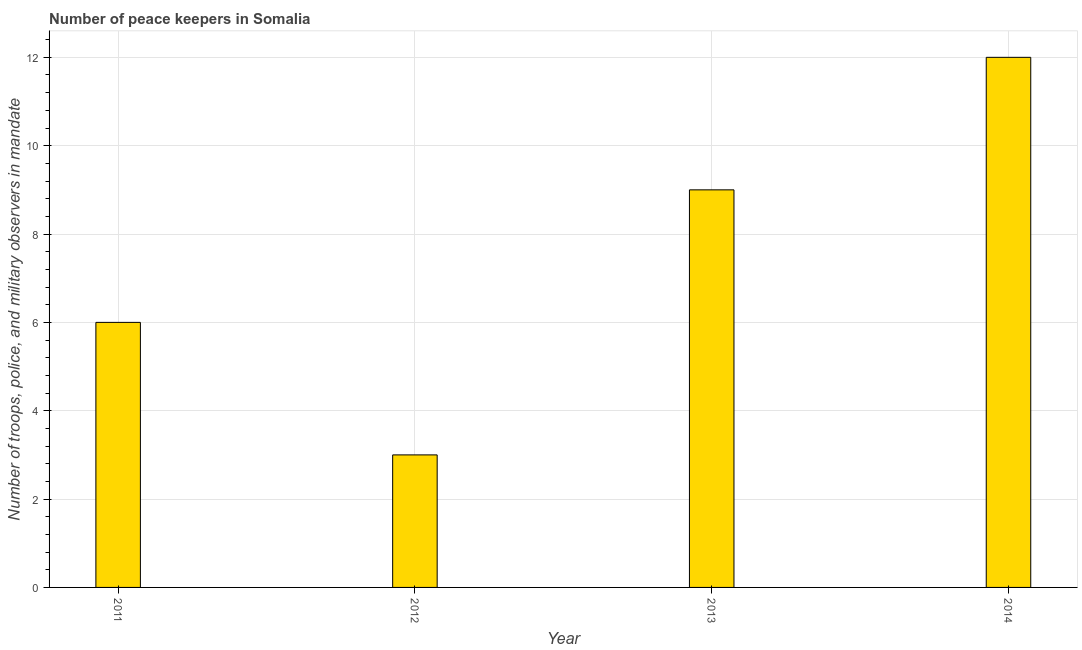Does the graph contain any zero values?
Offer a very short reply. No. What is the title of the graph?
Your response must be concise. Number of peace keepers in Somalia. What is the label or title of the Y-axis?
Keep it short and to the point. Number of troops, police, and military observers in mandate. Across all years, what is the maximum number of peace keepers?
Your answer should be compact. 12. Across all years, what is the minimum number of peace keepers?
Offer a very short reply. 3. In which year was the number of peace keepers maximum?
Keep it short and to the point. 2014. In which year was the number of peace keepers minimum?
Give a very brief answer. 2012. What is the sum of the number of peace keepers?
Your response must be concise. 30. What is the difference between the number of peace keepers in 2011 and 2014?
Ensure brevity in your answer.  -6. In how many years, is the number of peace keepers greater than the average number of peace keepers taken over all years?
Give a very brief answer. 2. How many bars are there?
Your answer should be very brief. 4. Are all the bars in the graph horizontal?
Make the answer very short. No. What is the difference between two consecutive major ticks on the Y-axis?
Provide a short and direct response. 2. What is the Number of troops, police, and military observers in mandate of 2011?
Make the answer very short. 6. What is the Number of troops, police, and military observers in mandate in 2012?
Make the answer very short. 3. What is the difference between the Number of troops, police, and military observers in mandate in 2011 and 2014?
Offer a very short reply. -6. What is the difference between the Number of troops, police, and military observers in mandate in 2013 and 2014?
Provide a succinct answer. -3. What is the ratio of the Number of troops, police, and military observers in mandate in 2011 to that in 2012?
Ensure brevity in your answer.  2. What is the ratio of the Number of troops, police, and military observers in mandate in 2011 to that in 2013?
Give a very brief answer. 0.67. What is the ratio of the Number of troops, police, and military observers in mandate in 2011 to that in 2014?
Give a very brief answer. 0.5. What is the ratio of the Number of troops, police, and military observers in mandate in 2012 to that in 2013?
Provide a succinct answer. 0.33. What is the ratio of the Number of troops, police, and military observers in mandate in 2013 to that in 2014?
Your answer should be compact. 0.75. 